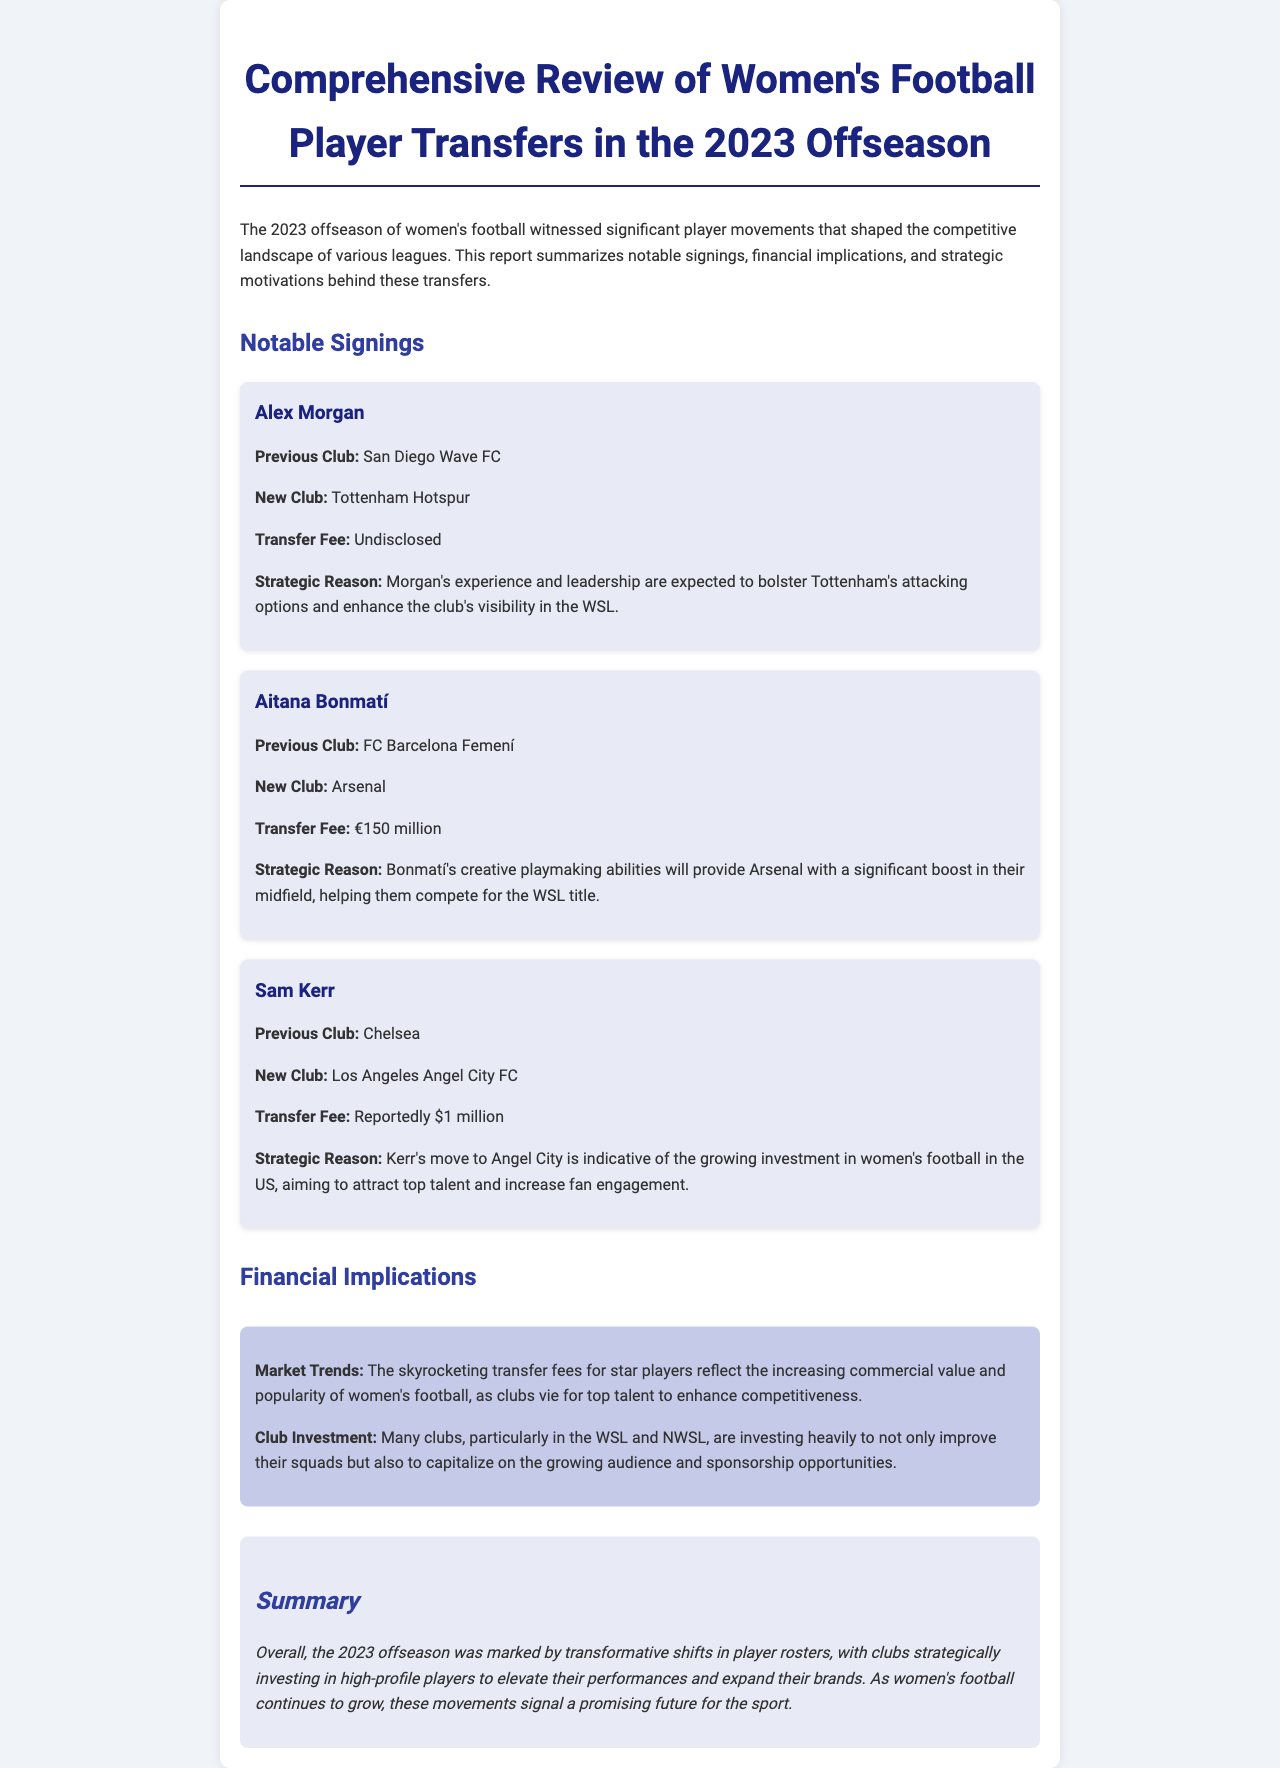What is the previous club of Alex Morgan? The document states Alex Morgan's previous club was San Diego Wave FC.
Answer: San Diego Wave FC What is the transfer fee for Aitana Bonmatí? The document specifies that Aitana Bonmatí's transfer fee was €150 million.
Answer: €150 million To which club has Sam Kerr transferred? According to the document, Sam Kerr has transferred to Los Angeles Angel City FC.
Answer: Los Angeles Angel City FC What is the strategic reason for Alex Morgan's transfer? The report mentions that Morgan's experience and leadership are expected to bolster Tottenham's attacking options.
Answer: Bolster Tottenham's attacking options What do the skyrocketing transfer fees reflect? The document indicates that the skyrocketing transfer fees reflect the increasing commercial value and popularity of women's football.
Answer: Increasing commercial value and popularity What is the focus of many clubs' investments in women's football? The document states that many clubs are investing to improve their squads and capitalize on the growing audience and sponsorship opportunities.
Answer: Improve squads and capitalize on audience What overall trend is observed in the 2023 offseason? The report highlights transformative shifts in player rosters as a significant trend in the 2023 offseason.
Answer: Transformative shifts in player rosters What is the document type of this report? This content presents a comprehensive review report about women's football player transfers.
Answer: Comprehensive review report 